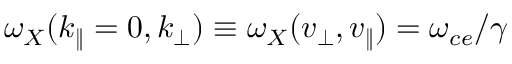Convert formula to latex. <formula><loc_0><loc_0><loc_500><loc_500>\omega _ { X } ( k _ { \| } = 0 , k _ { \perp } ) \equiv \omega _ { X } ( v _ { \perp } , v _ { \| } ) = \omega _ { c e } / \gamma</formula> 